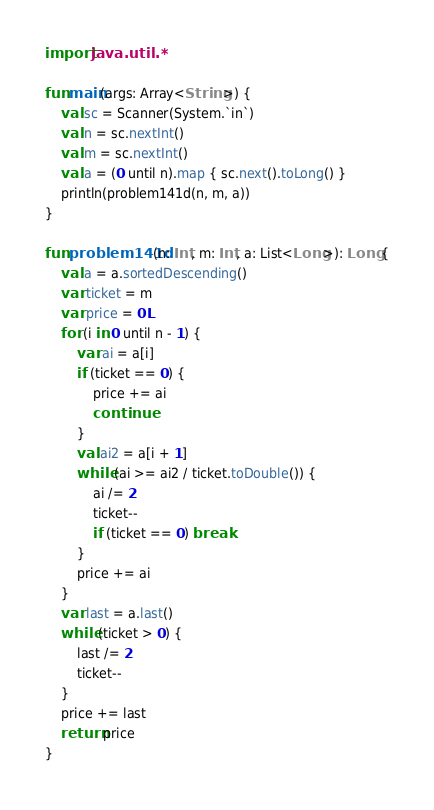<code> <loc_0><loc_0><loc_500><loc_500><_Kotlin_>import java.util.*

fun main(args: Array<String>) {
    val sc = Scanner(System.`in`)
    val n = sc.nextInt()
    val m = sc.nextInt()
    val a = (0 until n).map { sc.next().toLong() }
    println(problem141d(n, m, a))
}

fun problem141d(n: Int, m: Int, a: List<Long>): Long {
    val a = a.sortedDescending()
    var ticket = m
    var price = 0L
    for (i in 0 until n - 1) {
        var ai = a[i]
        if (ticket == 0) {
            price += ai
            continue
        }
        val ai2 = a[i + 1]
        while (ai >= ai2 / ticket.toDouble()) {
            ai /= 2
            ticket--
            if (ticket == 0) break
        }
        price += ai
    }
    var last = a.last()
    while (ticket > 0) {
        last /= 2
        ticket--
    }
    price += last
    return price
}</code> 